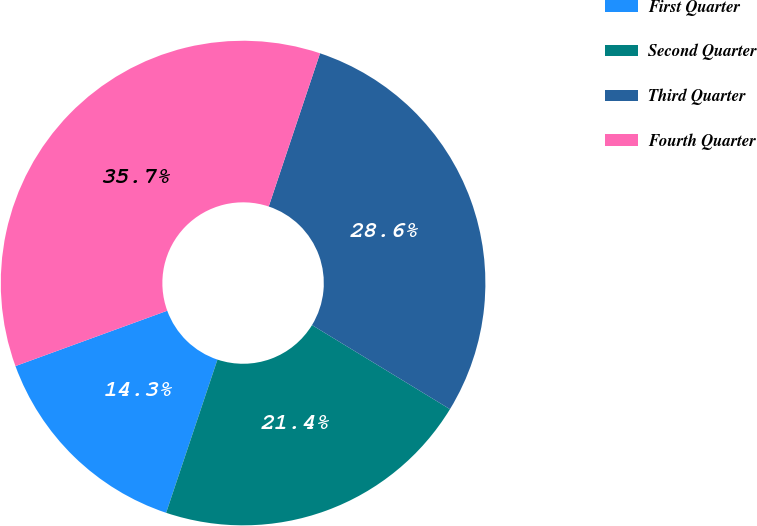Convert chart. <chart><loc_0><loc_0><loc_500><loc_500><pie_chart><fcel>First Quarter<fcel>Second Quarter<fcel>Third Quarter<fcel>Fourth Quarter<nl><fcel>14.29%<fcel>21.43%<fcel>28.57%<fcel>35.71%<nl></chart> 